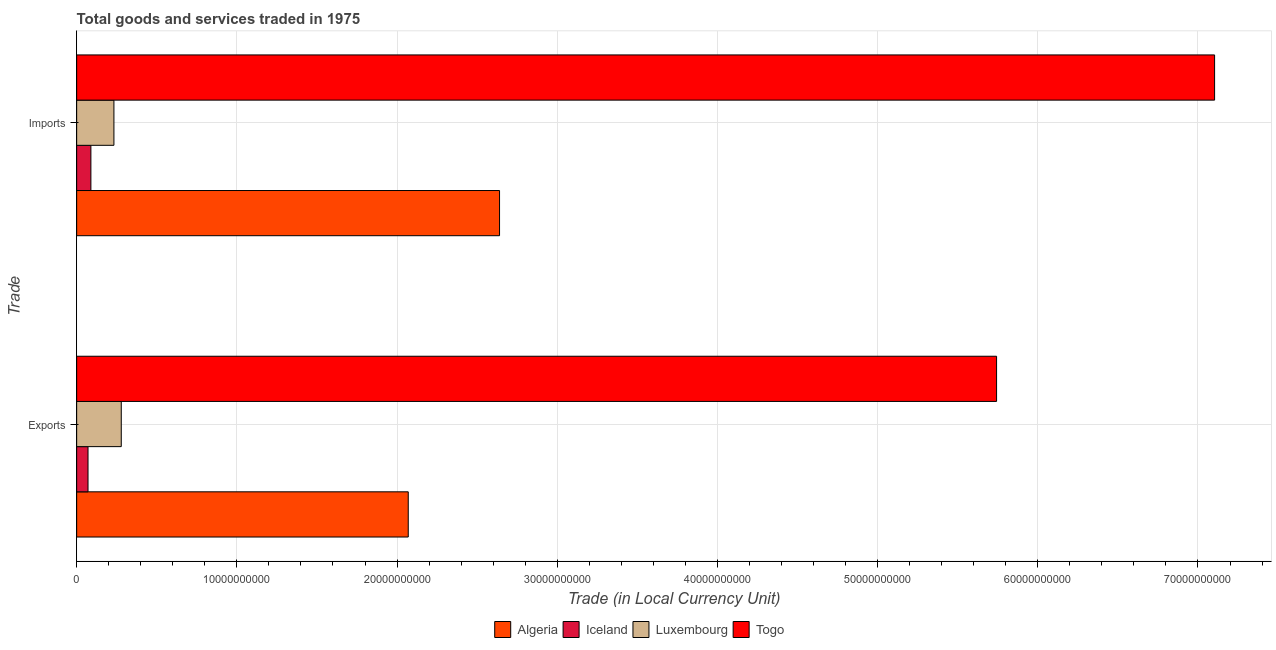How many different coloured bars are there?
Keep it short and to the point. 4. How many groups of bars are there?
Keep it short and to the point. 2. Are the number of bars on each tick of the Y-axis equal?
Provide a short and direct response. Yes. How many bars are there on the 2nd tick from the top?
Ensure brevity in your answer.  4. What is the label of the 1st group of bars from the top?
Your answer should be very brief. Imports. What is the imports of goods and services in Algeria?
Offer a terse response. 2.64e+1. Across all countries, what is the maximum export of goods and services?
Make the answer very short. 5.74e+1. Across all countries, what is the minimum imports of goods and services?
Your answer should be very brief. 8.88e+08. In which country was the imports of goods and services maximum?
Offer a terse response. Togo. In which country was the imports of goods and services minimum?
Ensure brevity in your answer.  Iceland. What is the total export of goods and services in the graph?
Ensure brevity in your answer.  8.16e+1. What is the difference between the export of goods and services in Algeria and that in Iceland?
Provide a short and direct response. 2.00e+1. What is the difference between the export of goods and services in Luxembourg and the imports of goods and services in Togo?
Offer a terse response. -6.83e+1. What is the average export of goods and services per country?
Keep it short and to the point. 2.04e+1. What is the difference between the imports of goods and services and export of goods and services in Luxembourg?
Give a very brief answer. -4.59e+08. In how many countries, is the imports of goods and services greater than 18000000000 LCU?
Make the answer very short. 2. What is the ratio of the export of goods and services in Iceland to that in Luxembourg?
Your answer should be compact. 0.25. In how many countries, is the export of goods and services greater than the average export of goods and services taken over all countries?
Ensure brevity in your answer.  2. What does the 4th bar from the bottom in Exports represents?
Offer a terse response. Togo. How many bars are there?
Your response must be concise. 8. Are the values on the major ticks of X-axis written in scientific E-notation?
Provide a succinct answer. No. Does the graph contain any zero values?
Provide a succinct answer. No. Does the graph contain grids?
Make the answer very short. Yes. Where does the legend appear in the graph?
Your response must be concise. Bottom center. How are the legend labels stacked?
Give a very brief answer. Horizontal. What is the title of the graph?
Offer a very short reply. Total goods and services traded in 1975. What is the label or title of the X-axis?
Provide a succinct answer. Trade (in Local Currency Unit). What is the label or title of the Y-axis?
Keep it short and to the point. Trade. What is the Trade (in Local Currency Unit) in Algeria in Exports?
Ensure brevity in your answer.  2.07e+1. What is the Trade (in Local Currency Unit) in Iceland in Exports?
Your answer should be compact. 7.09e+08. What is the Trade (in Local Currency Unit) of Luxembourg in Exports?
Your answer should be very brief. 2.78e+09. What is the Trade (in Local Currency Unit) in Togo in Exports?
Provide a short and direct response. 5.74e+1. What is the Trade (in Local Currency Unit) of Algeria in Imports?
Give a very brief answer. 2.64e+1. What is the Trade (in Local Currency Unit) of Iceland in Imports?
Ensure brevity in your answer.  8.88e+08. What is the Trade (in Local Currency Unit) of Luxembourg in Imports?
Your answer should be compact. 2.33e+09. What is the Trade (in Local Currency Unit) in Togo in Imports?
Keep it short and to the point. 7.10e+1. Across all Trade, what is the maximum Trade (in Local Currency Unit) of Algeria?
Provide a short and direct response. 2.64e+1. Across all Trade, what is the maximum Trade (in Local Currency Unit) in Iceland?
Provide a succinct answer. 8.88e+08. Across all Trade, what is the maximum Trade (in Local Currency Unit) of Luxembourg?
Provide a short and direct response. 2.78e+09. Across all Trade, what is the maximum Trade (in Local Currency Unit) in Togo?
Your answer should be very brief. 7.10e+1. Across all Trade, what is the minimum Trade (in Local Currency Unit) in Algeria?
Offer a very short reply. 2.07e+1. Across all Trade, what is the minimum Trade (in Local Currency Unit) in Iceland?
Ensure brevity in your answer.  7.09e+08. Across all Trade, what is the minimum Trade (in Local Currency Unit) in Luxembourg?
Make the answer very short. 2.33e+09. Across all Trade, what is the minimum Trade (in Local Currency Unit) in Togo?
Provide a succinct answer. 5.74e+1. What is the total Trade (in Local Currency Unit) in Algeria in the graph?
Give a very brief answer. 4.71e+1. What is the total Trade (in Local Currency Unit) of Iceland in the graph?
Offer a terse response. 1.60e+09. What is the total Trade (in Local Currency Unit) of Luxembourg in the graph?
Offer a very short reply. 5.11e+09. What is the total Trade (in Local Currency Unit) of Togo in the graph?
Offer a terse response. 1.28e+11. What is the difference between the Trade (in Local Currency Unit) in Algeria in Exports and that in Imports?
Give a very brief answer. -5.70e+09. What is the difference between the Trade (in Local Currency Unit) of Iceland in Exports and that in Imports?
Make the answer very short. -1.79e+08. What is the difference between the Trade (in Local Currency Unit) in Luxembourg in Exports and that in Imports?
Your response must be concise. 4.59e+08. What is the difference between the Trade (in Local Currency Unit) in Togo in Exports and that in Imports?
Provide a short and direct response. -1.36e+1. What is the difference between the Trade (in Local Currency Unit) of Algeria in Exports and the Trade (in Local Currency Unit) of Iceland in Imports?
Keep it short and to the point. 1.98e+1. What is the difference between the Trade (in Local Currency Unit) in Algeria in Exports and the Trade (in Local Currency Unit) in Luxembourg in Imports?
Make the answer very short. 1.84e+1. What is the difference between the Trade (in Local Currency Unit) in Algeria in Exports and the Trade (in Local Currency Unit) in Togo in Imports?
Your response must be concise. -5.03e+1. What is the difference between the Trade (in Local Currency Unit) in Iceland in Exports and the Trade (in Local Currency Unit) in Luxembourg in Imports?
Keep it short and to the point. -1.62e+09. What is the difference between the Trade (in Local Currency Unit) in Iceland in Exports and the Trade (in Local Currency Unit) in Togo in Imports?
Keep it short and to the point. -7.03e+1. What is the difference between the Trade (in Local Currency Unit) of Luxembourg in Exports and the Trade (in Local Currency Unit) of Togo in Imports?
Your answer should be very brief. -6.83e+1. What is the average Trade (in Local Currency Unit) in Algeria per Trade?
Keep it short and to the point. 2.36e+1. What is the average Trade (in Local Currency Unit) in Iceland per Trade?
Your response must be concise. 7.99e+08. What is the average Trade (in Local Currency Unit) in Luxembourg per Trade?
Keep it short and to the point. 2.56e+09. What is the average Trade (in Local Currency Unit) of Togo per Trade?
Give a very brief answer. 6.42e+1. What is the difference between the Trade (in Local Currency Unit) in Algeria and Trade (in Local Currency Unit) in Iceland in Exports?
Provide a succinct answer. 2.00e+1. What is the difference between the Trade (in Local Currency Unit) of Algeria and Trade (in Local Currency Unit) of Luxembourg in Exports?
Your response must be concise. 1.79e+1. What is the difference between the Trade (in Local Currency Unit) of Algeria and Trade (in Local Currency Unit) of Togo in Exports?
Give a very brief answer. -3.67e+1. What is the difference between the Trade (in Local Currency Unit) in Iceland and Trade (in Local Currency Unit) in Luxembourg in Exports?
Your answer should be very brief. -2.08e+09. What is the difference between the Trade (in Local Currency Unit) of Iceland and Trade (in Local Currency Unit) of Togo in Exports?
Offer a very short reply. -5.67e+1. What is the difference between the Trade (in Local Currency Unit) of Luxembourg and Trade (in Local Currency Unit) of Togo in Exports?
Offer a terse response. -5.46e+1. What is the difference between the Trade (in Local Currency Unit) of Algeria and Trade (in Local Currency Unit) of Iceland in Imports?
Offer a very short reply. 2.55e+1. What is the difference between the Trade (in Local Currency Unit) in Algeria and Trade (in Local Currency Unit) in Luxembourg in Imports?
Keep it short and to the point. 2.41e+1. What is the difference between the Trade (in Local Currency Unit) of Algeria and Trade (in Local Currency Unit) of Togo in Imports?
Your answer should be compact. -4.46e+1. What is the difference between the Trade (in Local Currency Unit) in Iceland and Trade (in Local Currency Unit) in Luxembourg in Imports?
Provide a short and direct response. -1.44e+09. What is the difference between the Trade (in Local Currency Unit) of Iceland and Trade (in Local Currency Unit) of Togo in Imports?
Offer a very short reply. -7.02e+1. What is the difference between the Trade (in Local Currency Unit) in Luxembourg and Trade (in Local Currency Unit) in Togo in Imports?
Your answer should be compact. -6.87e+1. What is the ratio of the Trade (in Local Currency Unit) in Algeria in Exports to that in Imports?
Your answer should be very brief. 0.78. What is the ratio of the Trade (in Local Currency Unit) in Iceland in Exports to that in Imports?
Keep it short and to the point. 0.8. What is the ratio of the Trade (in Local Currency Unit) in Luxembourg in Exports to that in Imports?
Ensure brevity in your answer.  1.2. What is the ratio of the Trade (in Local Currency Unit) in Togo in Exports to that in Imports?
Offer a very short reply. 0.81. What is the difference between the highest and the second highest Trade (in Local Currency Unit) in Algeria?
Ensure brevity in your answer.  5.70e+09. What is the difference between the highest and the second highest Trade (in Local Currency Unit) of Iceland?
Offer a very short reply. 1.79e+08. What is the difference between the highest and the second highest Trade (in Local Currency Unit) of Luxembourg?
Keep it short and to the point. 4.59e+08. What is the difference between the highest and the second highest Trade (in Local Currency Unit) of Togo?
Offer a terse response. 1.36e+1. What is the difference between the highest and the lowest Trade (in Local Currency Unit) of Algeria?
Provide a short and direct response. 5.70e+09. What is the difference between the highest and the lowest Trade (in Local Currency Unit) of Iceland?
Offer a terse response. 1.79e+08. What is the difference between the highest and the lowest Trade (in Local Currency Unit) in Luxembourg?
Make the answer very short. 4.59e+08. What is the difference between the highest and the lowest Trade (in Local Currency Unit) of Togo?
Make the answer very short. 1.36e+1. 